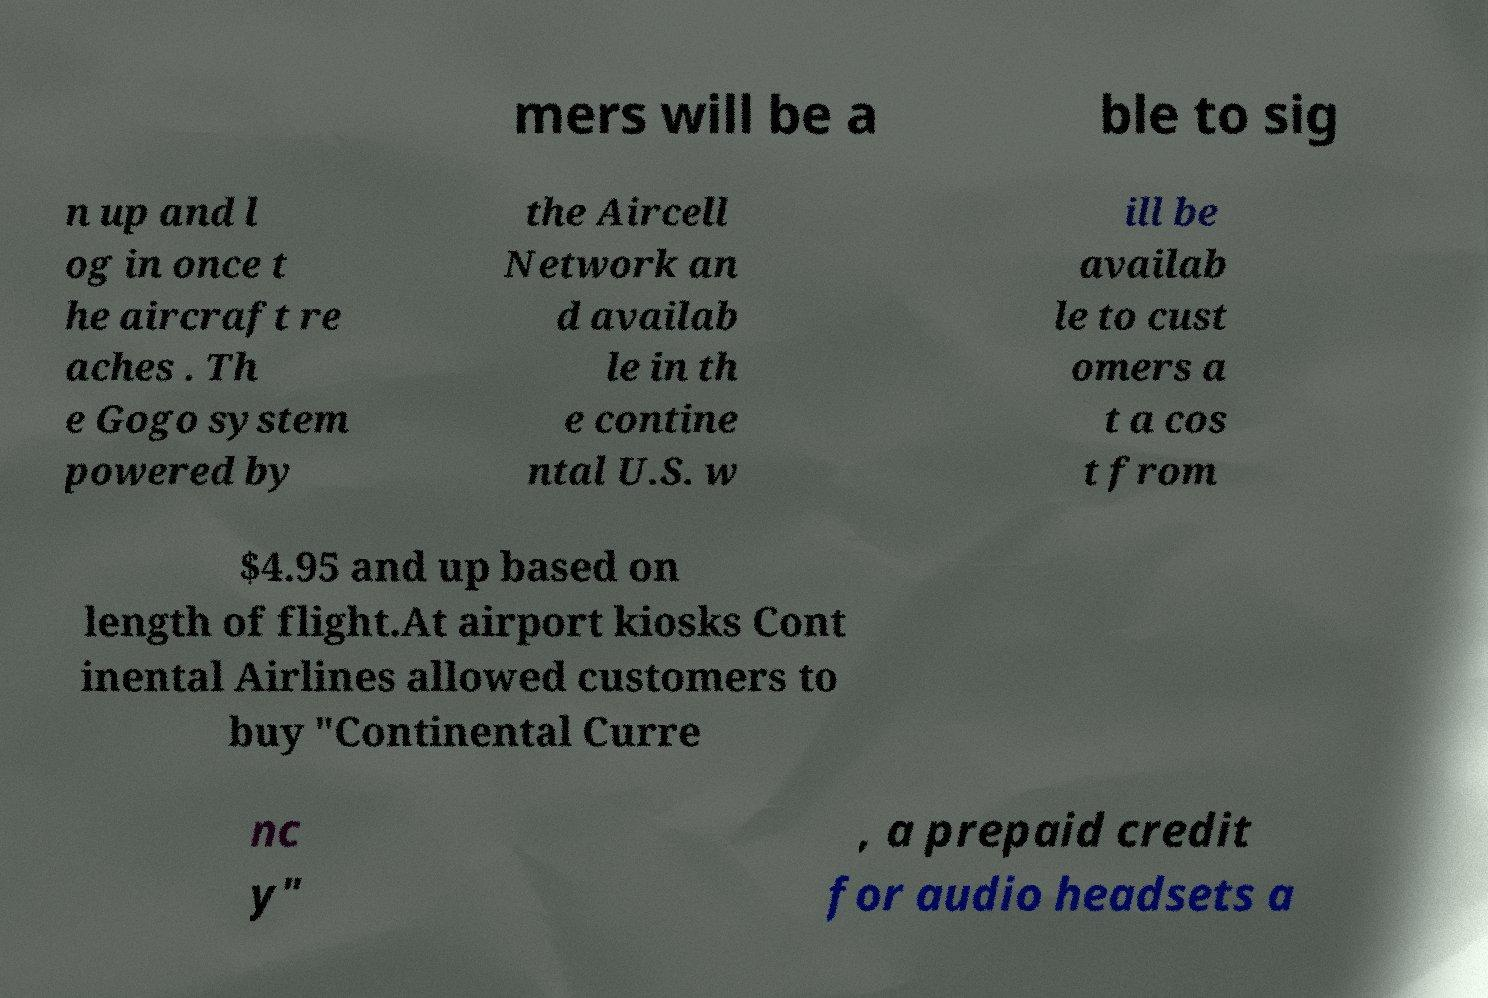What messages or text are displayed in this image? I need them in a readable, typed format. mers will be a ble to sig n up and l og in once t he aircraft re aches . Th e Gogo system powered by the Aircell Network an d availab le in th e contine ntal U.S. w ill be availab le to cust omers a t a cos t from $4.95 and up based on length of flight.At airport kiosks Cont inental Airlines allowed customers to buy "Continental Curre nc y" , a prepaid credit for audio headsets a 